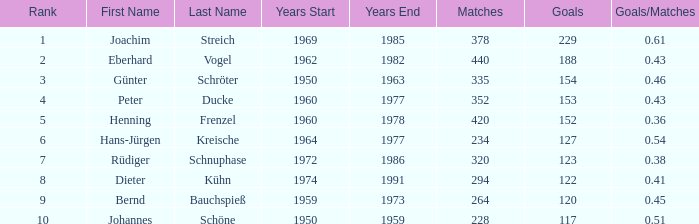How many goals/matches have 153 as the goals with matches greater than 352? None. 